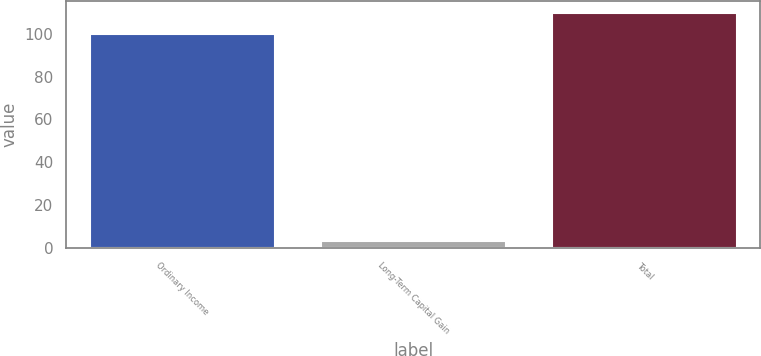Convert chart. <chart><loc_0><loc_0><loc_500><loc_500><bar_chart><fcel>Ordinary Income<fcel>Long-Term Capital Gain<fcel>Total<nl><fcel>100<fcel>3.31<fcel>109.67<nl></chart> 